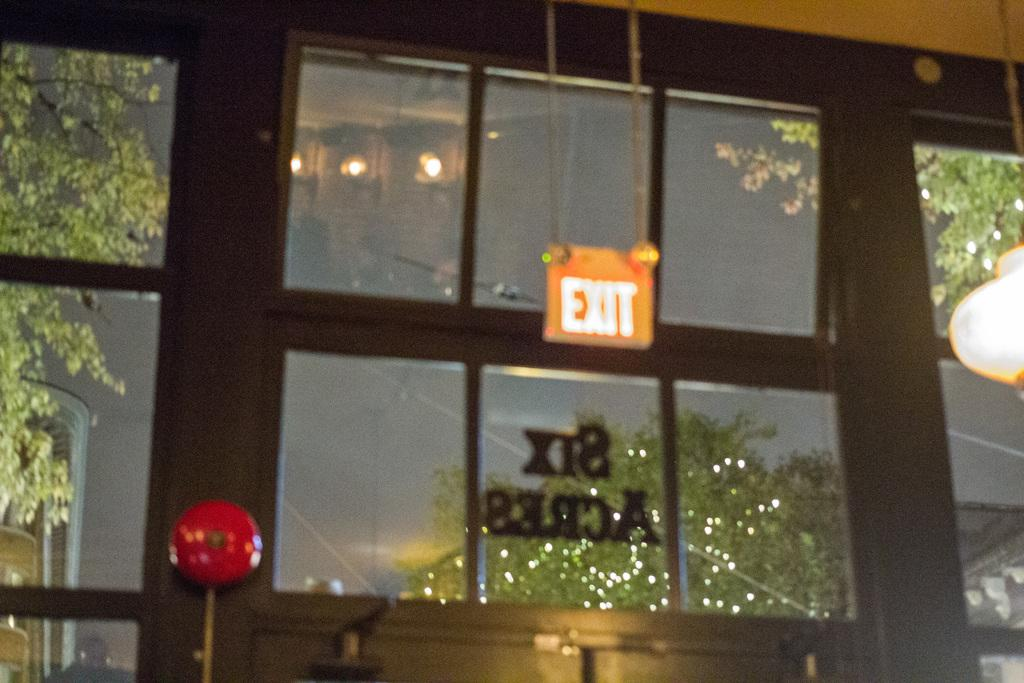What type of board is present in the image? There is an exit board in the image. What type of lighting is present in the image? There are ceiling lights in the image. What type of windows are present in the image? There are glass windows in the image. What can be seen through the windows in the image? Trees are visible through the windows in the image. How would you describe the sky in the image? The sky is dark in the image. Can you tell me the position of the rat in the image? There is no rat present in the image. What type of error is depicted on the exit board in the image? The exit board in the image does not depict any errors; it simply provides information about exits. 